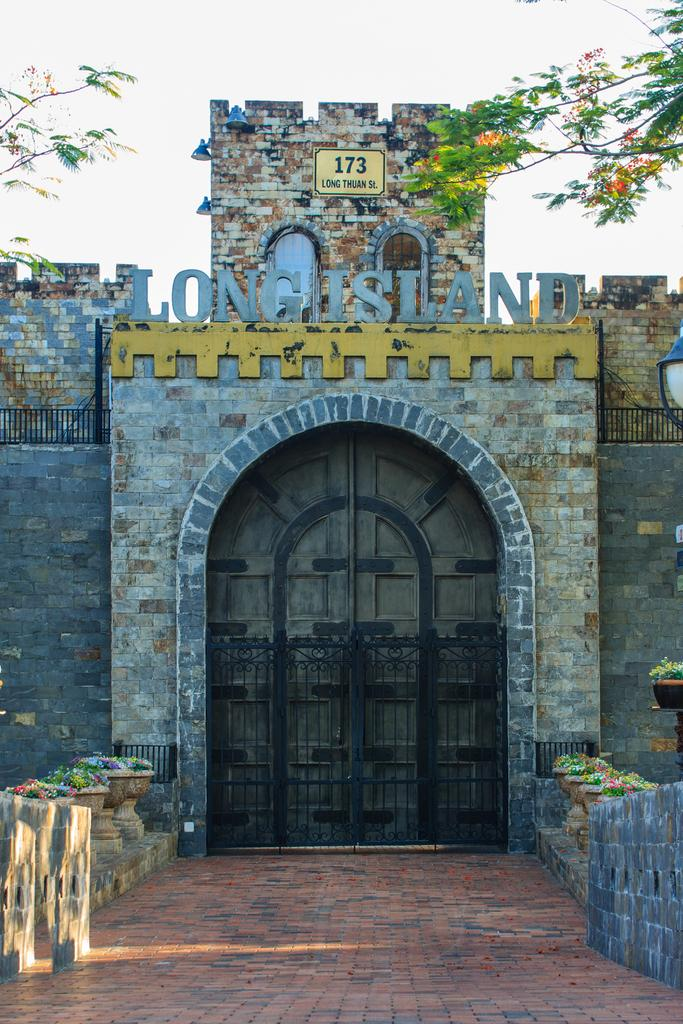What type of structure is depicted in the image? There is a wall with a gate and doors in the image. What is in front of the gate? There is a walkway and houseplants in front of the gate. What is the layout of the area in front of the gate? There is a wall in front of the gate. What can be seen at the top of the image? A tree and the sky are visible at the top of the image. What type of business can be seen operating near the seashore in the image? There is no seashore or business present in the image; it features a wall with a gate and doors, along with a walkway, houseplants, and a tree. Can you tell me where the dock is located in the image? There is no dock present in the image. 